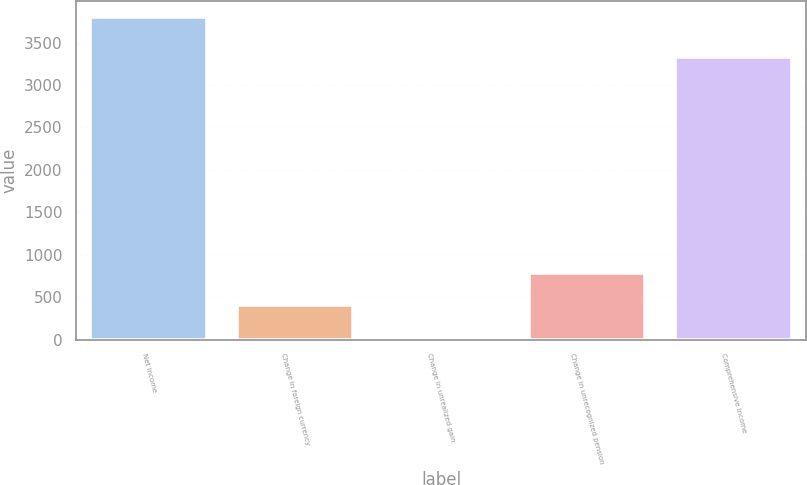<chart> <loc_0><loc_0><loc_500><loc_500><bar_chart><fcel>Net income<fcel>Change in foreign currency<fcel>Change in unrealized gain<fcel>Change in unrecognized pension<fcel>Comprehensive income<nl><fcel>3804<fcel>411.9<fcel>35<fcel>788.8<fcel>3336<nl></chart> 